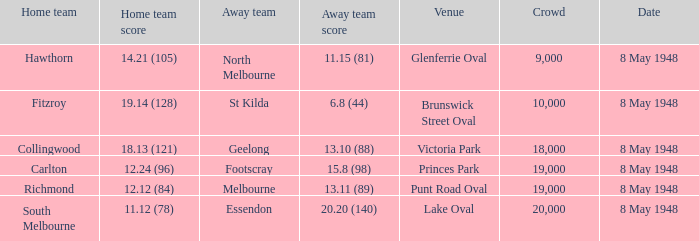Which home team has a score of 11.12 (78)? South Melbourne. 